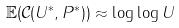Convert formula to latex. <formula><loc_0><loc_0><loc_500><loc_500>\mathbb { E } ( \mathcal { C } ( U ^ { * } , P ^ { * } ) ) \approx \log \log U</formula> 